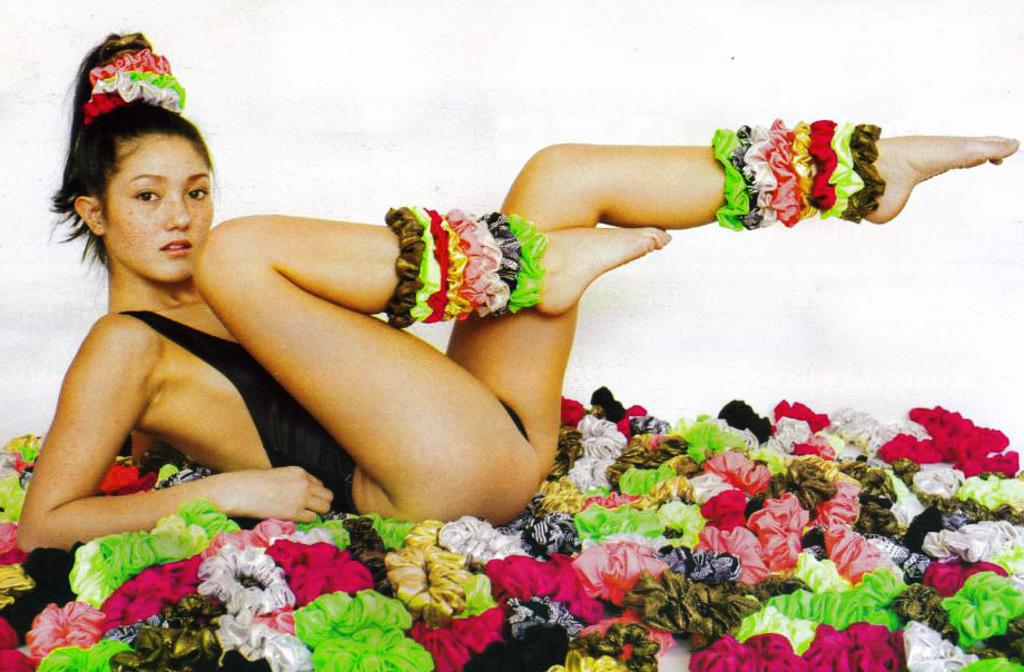Who is present in the image? There is a woman in the image. What is the woman doing in the image? The woman is lying on the floor. What accessories does the woman have in the image? The woman has hair bands. What can be seen in the background of the image? There is a wall in the background of the image. What type of goldfish is swimming in the woman's hair in the image? There are no goldfish present in the image; the woman has hair bands, not goldfish. 